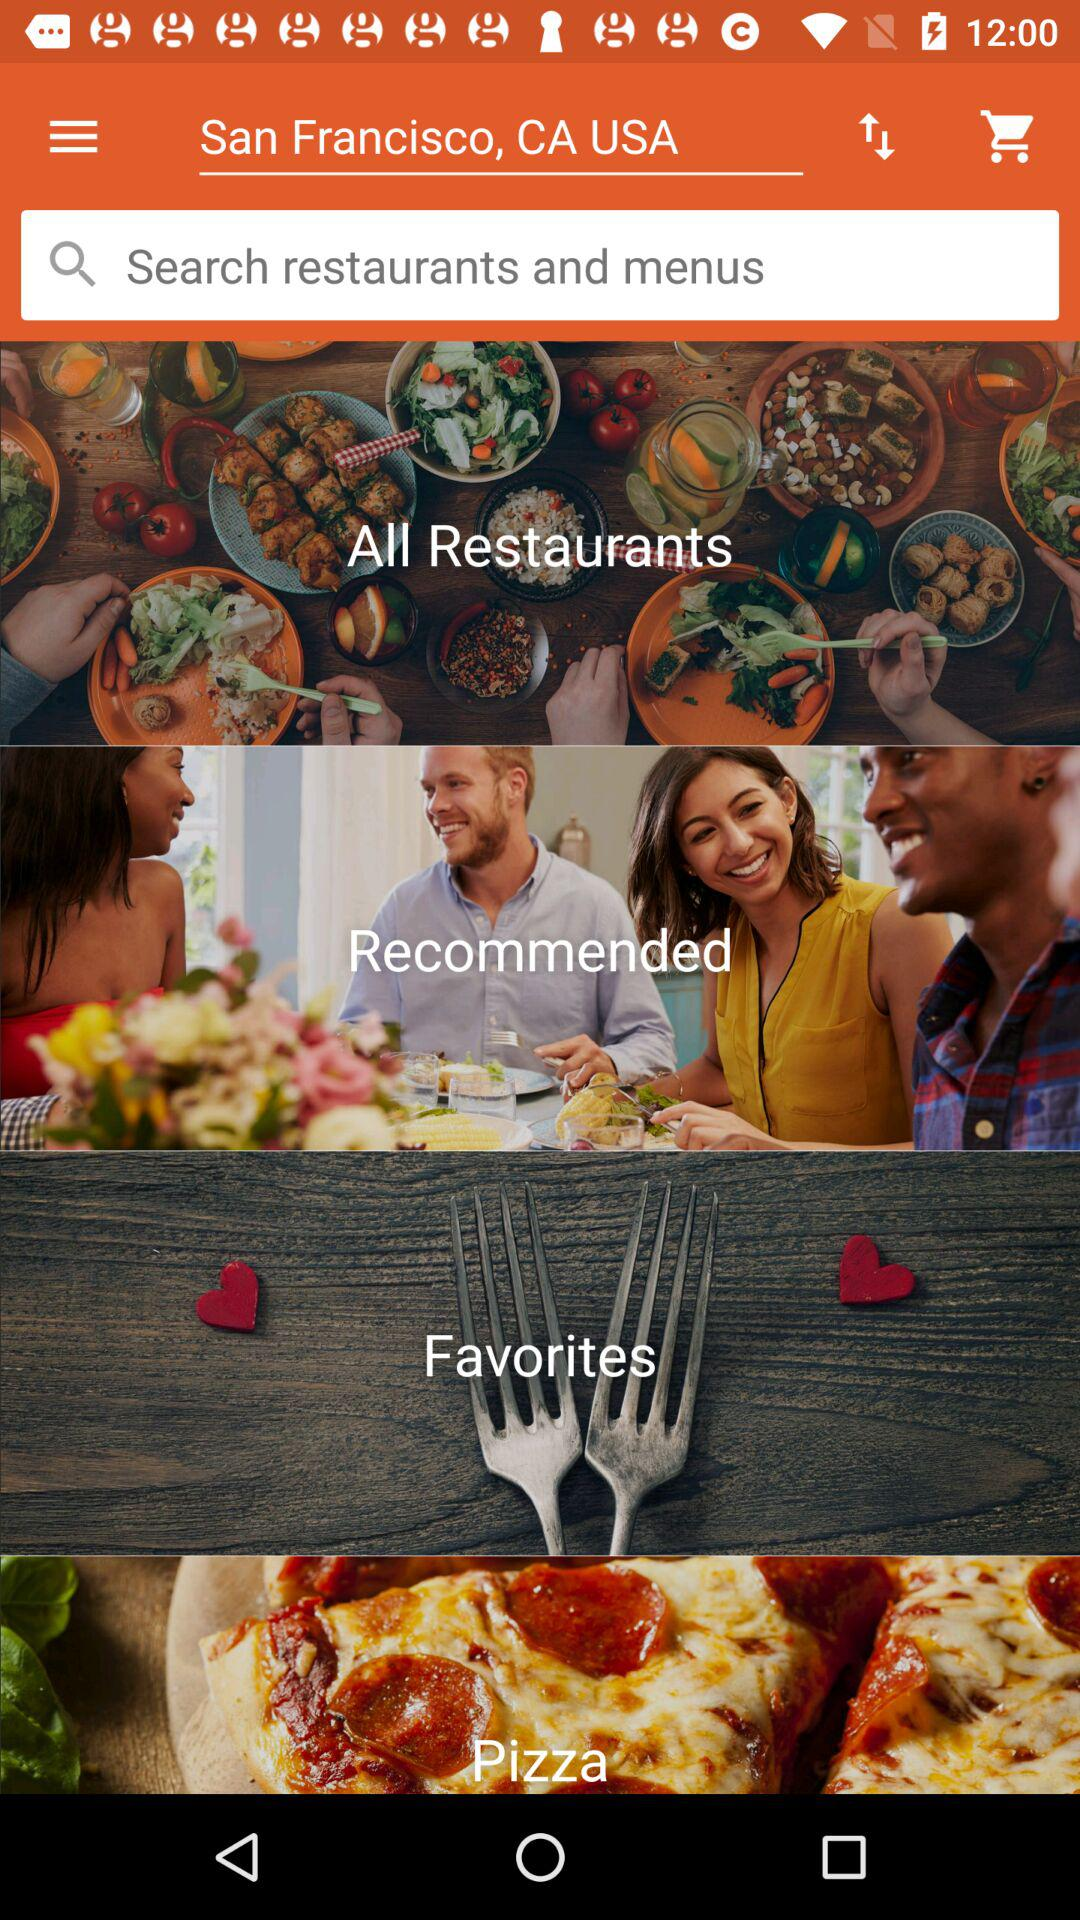What is the mentioned location? The mentioned location is San Francisco, CA, USA. 